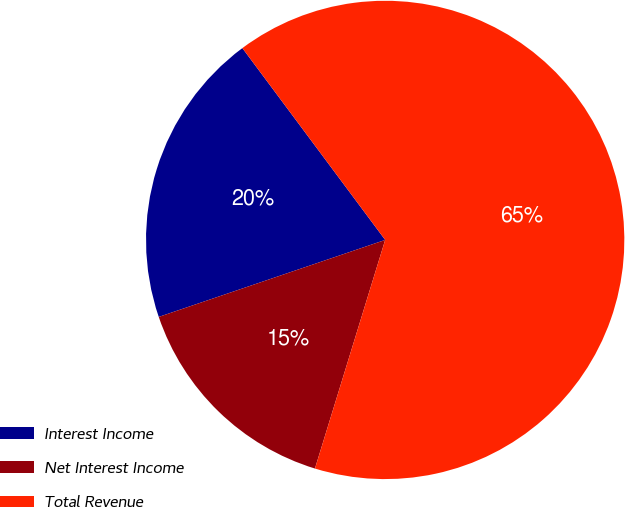<chart> <loc_0><loc_0><loc_500><loc_500><pie_chart><fcel>Interest Income<fcel>Net Interest Income<fcel>Total Revenue<nl><fcel>20.03%<fcel>15.04%<fcel>64.93%<nl></chart> 